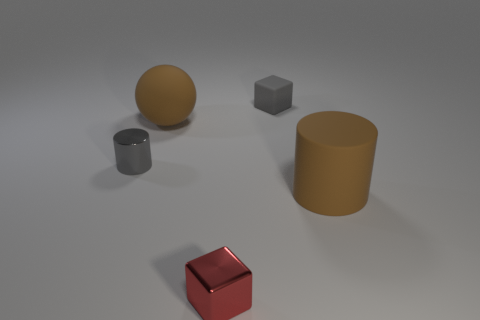Do the matte sphere and the large cylinder have the same color?
Offer a terse response. Yes. Are there any other things that are the same shape as the gray matte object?
Provide a short and direct response. Yes. Do the gray metal object and the object in front of the matte cylinder have the same shape?
Provide a succinct answer. No. There is a gray matte object that is the same shape as the red shiny thing; what size is it?
Ensure brevity in your answer.  Small. How many other things are made of the same material as the gray block?
Your answer should be compact. 2. What is the material of the brown ball?
Your answer should be very brief. Rubber. Is the color of the small cube in front of the tiny cylinder the same as the large thing on the left side of the gray rubber cube?
Offer a very short reply. No. Are there more big brown cylinders that are to the right of the sphere than tiny shiny cylinders?
Your answer should be compact. No. What number of other things are the same color as the large cylinder?
Your response must be concise. 1. Is the size of the block that is behind the matte sphere the same as the rubber sphere?
Offer a very short reply. No. 